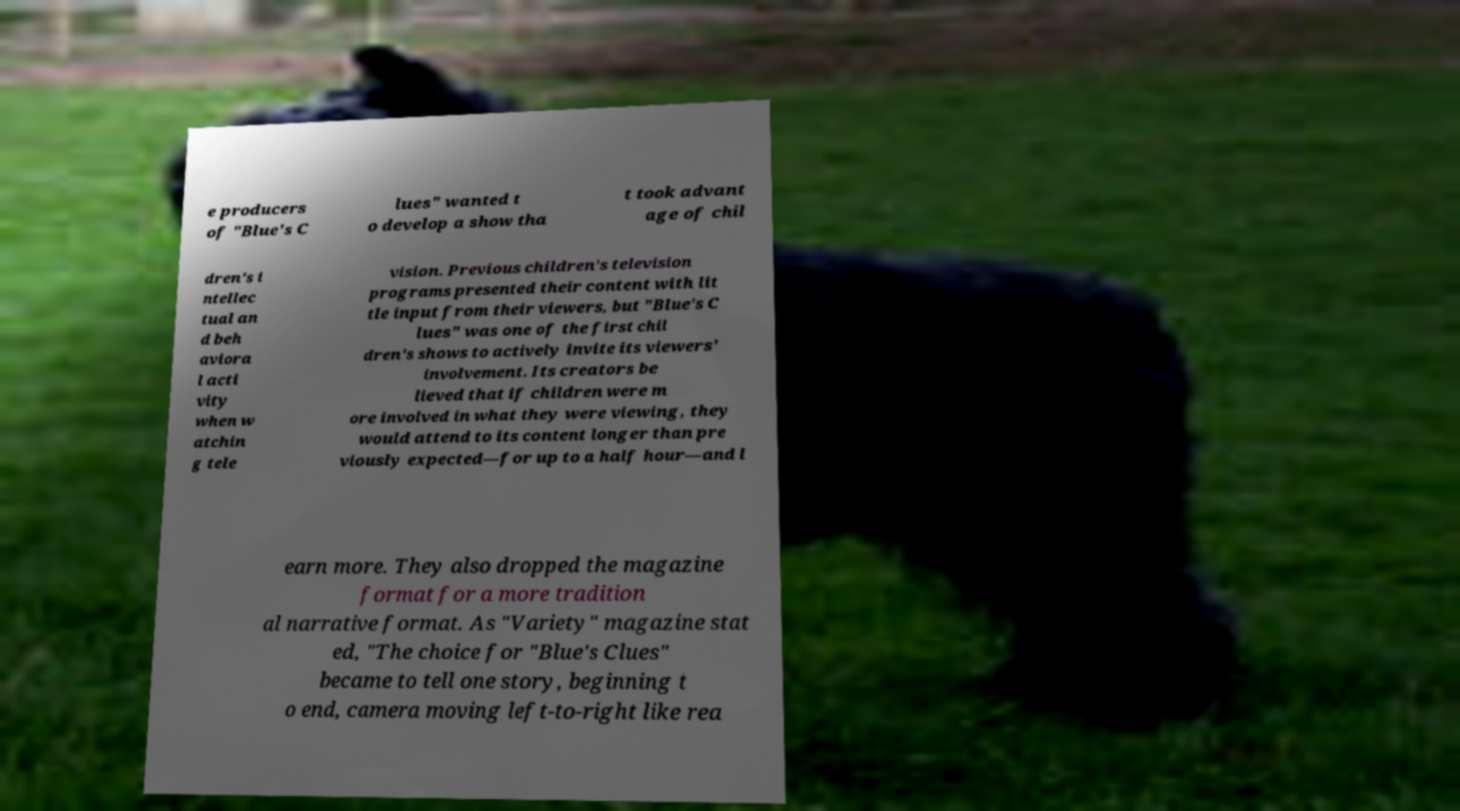I need the written content from this picture converted into text. Can you do that? e producers of "Blue's C lues" wanted t o develop a show tha t took advant age of chil dren's i ntellec tual an d beh aviora l acti vity when w atchin g tele vision. Previous children's television programs presented their content with lit tle input from their viewers, but "Blue's C lues" was one of the first chil dren's shows to actively invite its viewers' involvement. Its creators be lieved that if children were m ore involved in what they were viewing, they would attend to its content longer than pre viously expected—for up to a half hour—and l earn more. They also dropped the magazine format for a more tradition al narrative format. As "Variety" magazine stat ed, "The choice for "Blue's Clues" became to tell one story, beginning t o end, camera moving left-to-right like rea 